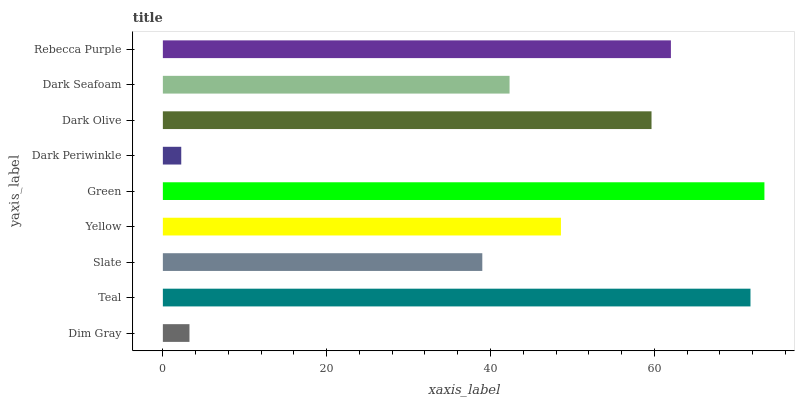Is Dark Periwinkle the minimum?
Answer yes or no. Yes. Is Green the maximum?
Answer yes or no. Yes. Is Teal the minimum?
Answer yes or no. No. Is Teal the maximum?
Answer yes or no. No. Is Teal greater than Dim Gray?
Answer yes or no. Yes. Is Dim Gray less than Teal?
Answer yes or no. Yes. Is Dim Gray greater than Teal?
Answer yes or no. No. Is Teal less than Dim Gray?
Answer yes or no. No. Is Yellow the high median?
Answer yes or no. Yes. Is Yellow the low median?
Answer yes or no. Yes. Is Teal the high median?
Answer yes or no. No. Is Dim Gray the low median?
Answer yes or no. No. 